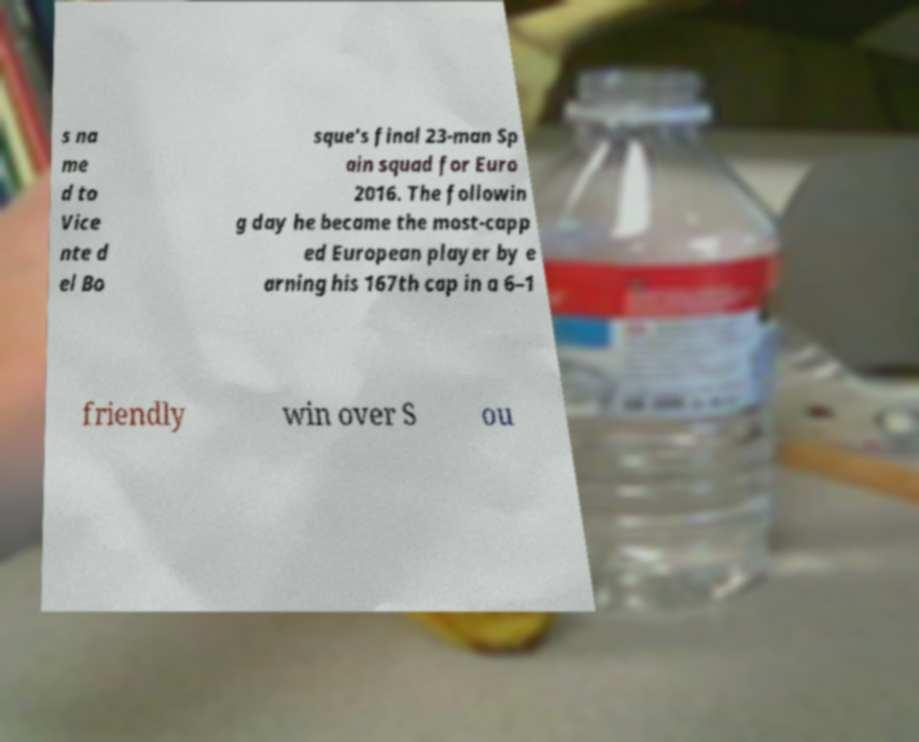Could you assist in decoding the text presented in this image and type it out clearly? s na me d to Vice nte d el Bo sque's final 23-man Sp ain squad for Euro 2016. The followin g day he became the most-capp ed European player by e arning his 167th cap in a 6–1 friendly win over S ou 